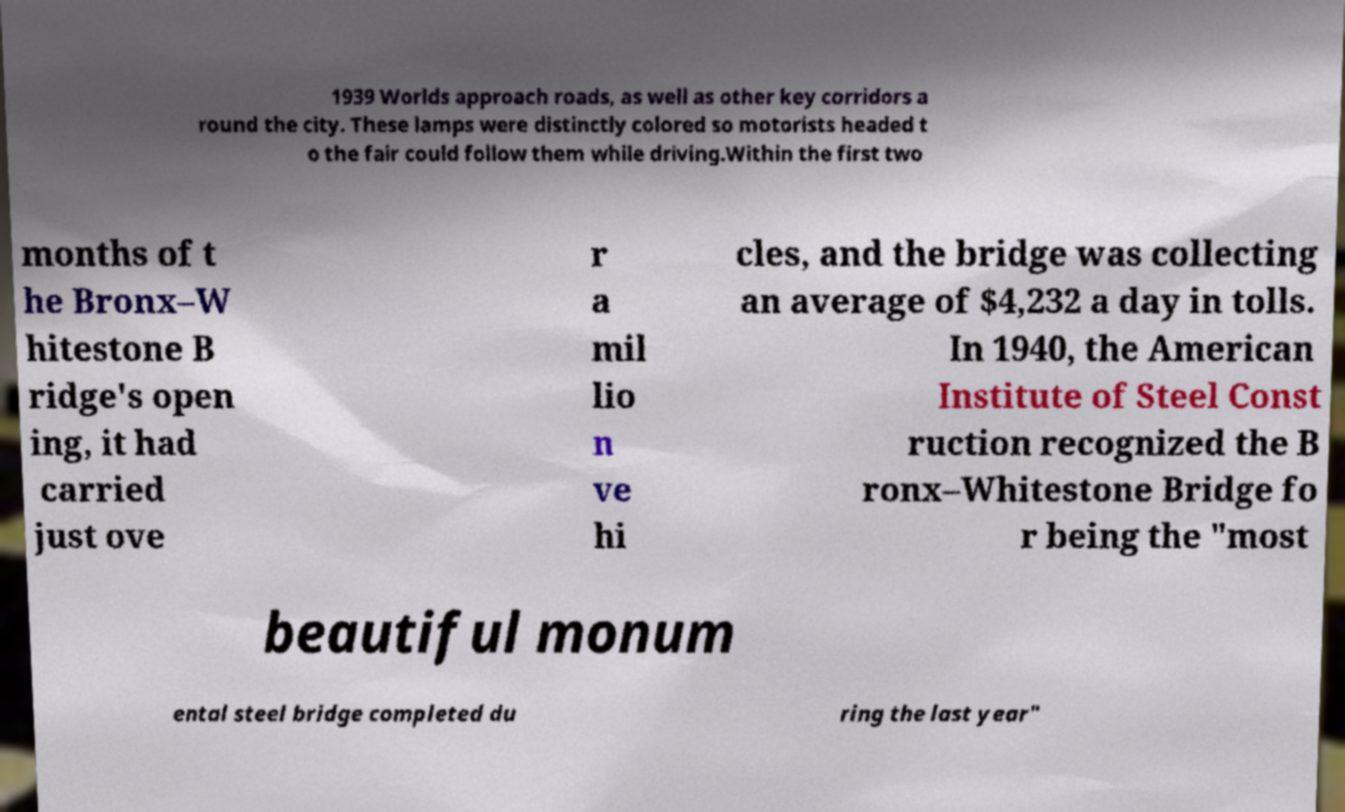Can you read and provide the text displayed in the image?This photo seems to have some interesting text. Can you extract and type it out for me? 1939 Worlds approach roads, as well as other key corridors a round the city. These lamps were distinctly colored so motorists headed t o the fair could follow them while driving.Within the first two months of t he Bronx–W hitestone B ridge's open ing, it had carried just ove r a mil lio n ve hi cles, and the bridge was collecting an average of $4,232 a day in tolls. In 1940, the American Institute of Steel Const ruction recognized the B ronx–Whitestone Bridge fo r being the "most beautiful monum ental steel bridge completed du ring the last year" 